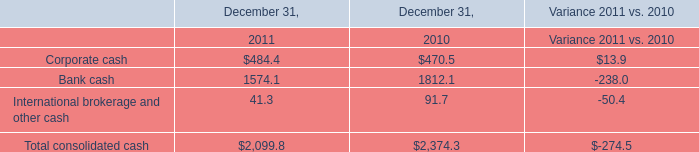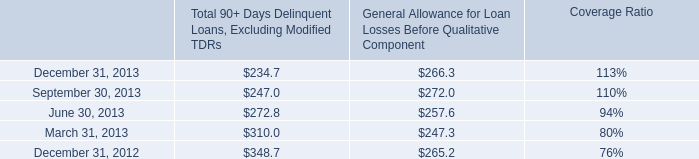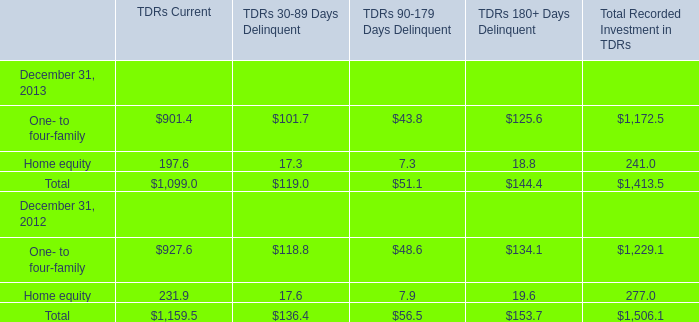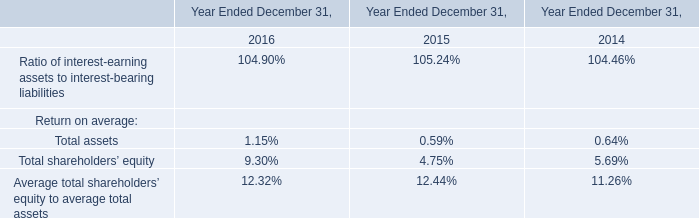What is the growing rate of General Allowance for Loan Losses Before Qualitative Component in the year with the least Total 90+ Days Delinquent Loans, Excluding Modified TDRs? 
Computations: ((266.3 - 265.2) / 265.2)
Answer: 0.00415. 